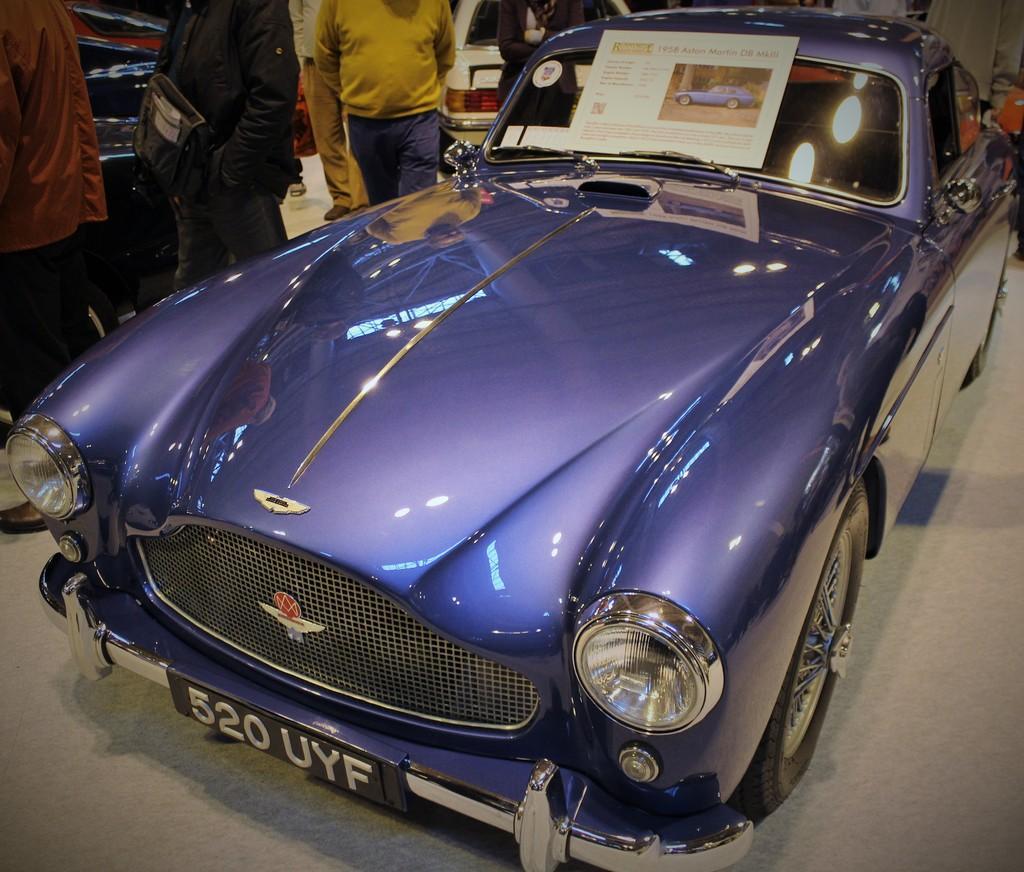Can you describe this image briefly? In this image we can see a violet color car is on the road, beside the car there are a few people standing. Above the car there is a poster. 